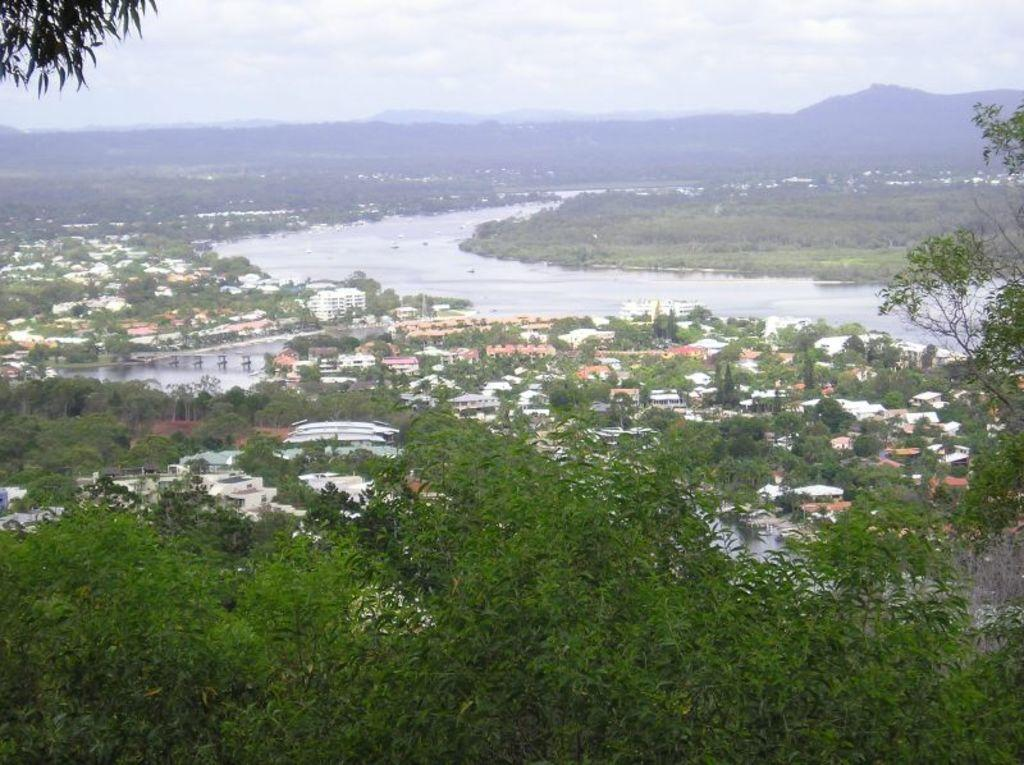What type of natural elements can be seen in the image? There are trees in the image. What type of man-made structures are present in the image? There are buildings in the image. What is the water feature in the image? There is water visible in the image. What can be seen in the background of the image? There are hills and the sky visible in the background of the image. What is the condition of the sky in the image? Clouds are present in the sky. Where is the button located in the image? There is no button present in the image. What type of transportation facility can be seen in the image? There is no airport or any transportation facility visible in the image. What type of electrical infrastructure can be seen in the image? There is no wire or any electrical infrastructure visible in the image. 